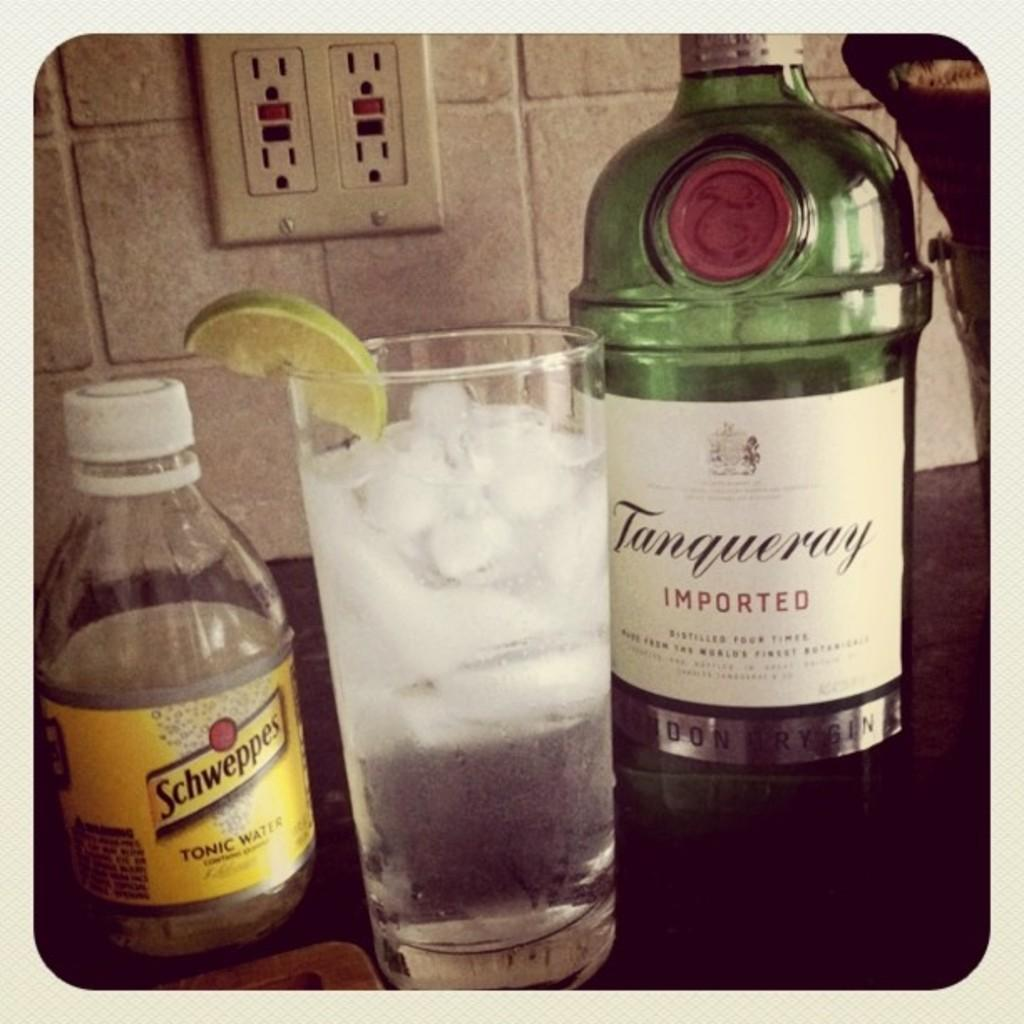Provide a one-sentence caption for the provided image. Schweppers tonic water is am option to mix into a drink. 